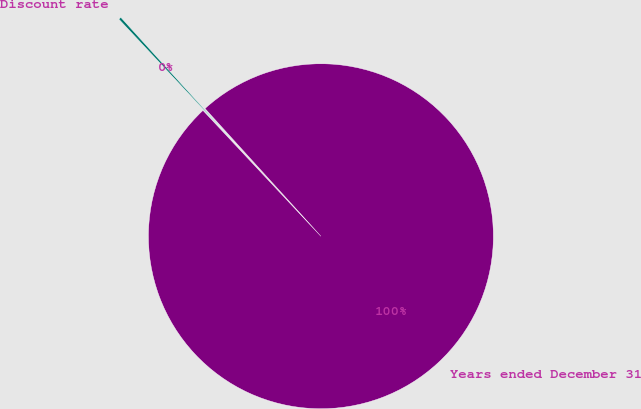Convert chart to OTSL. <chart><loc_0><loc_0><loc_500><loc_500><pie_chart><fcel>Years ended December 31<fcel>Discount rate<nl><fcel>99.75%<fcel>0.25%<nl></chart> 